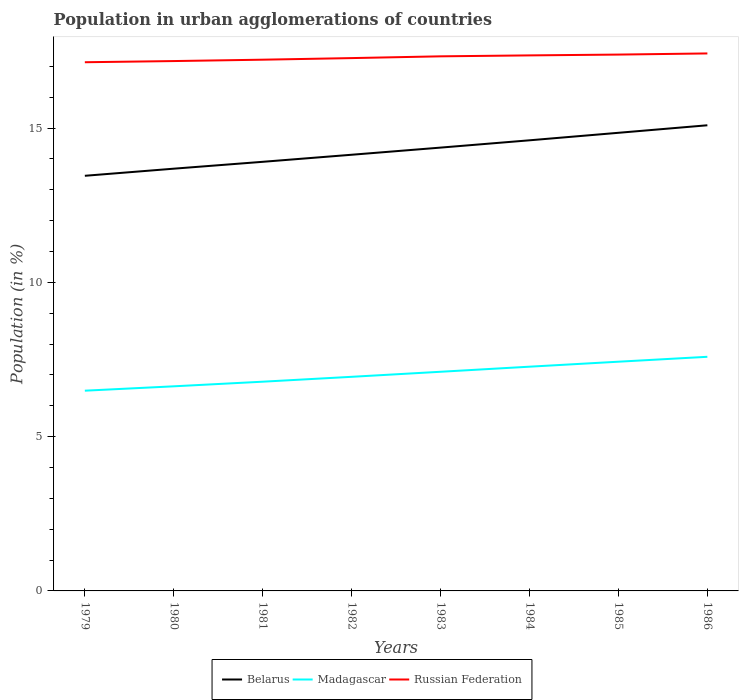Is the number of lines equal to the number of legend labels?
Keep it short and to the point. Yes. Across all years, what is the maximum percentage of population in urban agglomerations in Russian Federation?
Your response must be concise. 17.14. In which year was the percentage of population in urban agglomerations in Madagascar maximum?
Keep it short and to the point. 1979. What is the total percentage of population in urban agglomerations in Madagascar in the graph?
Offer a terse response. -0.49. What is the difference between the highest and the second highest percentage of population in urban agglomerations in Madagascar?
Ensure brevity in your answer.  1.1. Is the percentage of population in urban agglomerations in Madagascar strictly greater than the percentage of population in urban agglomerations in Belarus over the years?
Offer a terse response. Yes. Are the values on the major ticks of Y-axis written in scientific E-notation?
Ensure brevity in your answer.  No. Does the graph contain any zero values?
Your response must be concise. No. Does the graph contain grids?
Give a very brief answer. No. Where does the legend appear in the graph?
Provide a succinct answer. Bottom center. What is the title of the graph?
Your answer should be compact. Population in urban agglomerations of countries. What is the label or title of the X-axis?
Provide a succinct answer. Years. What is the Population (in %) of Belarus in 1979?
Your answer should be compact. 13.46. What is the Population (in %) of Madagascar in 1979?
Your answer should be compact. 6.49. What is the Population (in %) of Russian Federation in 1979?
Give a very brief answer. 17.14. What is the Population (in %) in Belarus in 1980?
Your response must be concise. 13.69. What is the Population (in %) of Madagascar in 1980?
Offer a very short reply. 6.63. What is the Population (in %) in Russian Federation in 1980?
Ensure brevity in your answer.  17.17. What is the Population (in %) of Belarus in 1981?
Your response must be concise. 13.91. What is the Population (in %) of Madagascar in 1981?
Give a very brief answer. 6.78. What is the Population (in %) in Russian Federation in 1981?
Your answer should be compact. 17.22. What is the Population (in %) of Belarus in 1982?
Keep it short and to the point. 14.14. What is the Population (in %) in Madagascar in 1982?
Your answer should be compact. 6.94. What is the Population (in %) of Russian Federation in 1982?
Give a very brief answer. 17.27. What is the Population (in %) of Belarus in 1983?
Offer a terse response. 14.37. What is the Population (in %) of Madagascar in 1983?
Your answer should be compact. 7.1. What is the Population (in %) of Russian Federation in 1983?
Offer a very short reply. 17.33. What is the Population (in %) in Belarus in 1984?
Your answer should be very brief. 14.61. What is the Population (in %) in Madagascar in 1984?
Your answer should be compact. 7.27. What is the Population (in %) in Russian Federation in 1984?
Your response must be concise. 17.36. What is the Population (in %) in Belarus in 1985?
Your answer should be very brief. 14.85. What is the Population (in %) in Madagascar in 1985?
Your response must be concise. 7.43. What is the Population (in %) of Russian Federation in 1985?
Keep it short and to the point. 17.38. What is the Population (in %) of Belarus in 1986?
Offer a terse response. 15.09. What is the Population (in %) in Madagascar in 1986?
Offer a very short reply. 7.59. What is the Population (in %) of Russian Federation in 1986?
Your response must be concise. 17.42. Across all years, what is the maximum Population (in %) in Belarus?
Offer a terse response. 15.09. Across all years, what is the maximum Population (in %) in Madagascar?
Make the answer very short. 7.59. Across all years, what is the maximum Population (in %) of Russian Federation?
Keep it short and to the point. 17.42. Across all years, what is the minimum Population (in %) of Belarus?
Your answer should be compact. 13.46. Across all years, what is the minimum Population (in %) of Madagascar?
Make the answer very short. 6.49. Across all years, what is the minimum Population (in %) in Russian Federation?
Offer a very short reply. 17.14. What is the total Population (in %) of Belarus in the graph?
Provide a succinct answer. 114.1. What is the total Population (in %) of Madagascar in the graph?
Make the answer very short. 56.23. What is the total Population (in %) in Russian Federation in the graph?
Your answer should be very brief. 138.29. What is the difference between the Population (in %) in Belarus in 1979 and that in 1980?
Make the answer very short. -0.23. What is the difference between the Population (in %) of Madagascar in 1979 and that in 1980?
Your answer should be very brief. -0.14. What is the difference between the Population (in %) of Russian Federation in 1979 and that in 1980?
Provide a succinct answer. -0.04. What is the difference between the Population (in %) of Belarus in 1979 and that in 1981?
Keep it short and to the point. -0.45. What is the difference between the Population (in %) of Madagascar in 1979 and that in 1981?
Provide a short and direct response. -0.29. What is the difference between the Population (in %) of Russian Federation in 1979 and that in 1981?
Make the answer very short. -0.08. What is the difference between the Population (in %) of Belarus in 1979 and that in 1982?
Offer a terse response. -0.68. What is the difference between the Population (in %) in Madagascar in 1979 and that in 1982?
Provide a short and direct response. -0.45. What is the difference between the Population (in %) of Russian Federation in 1979 and that in 1982?
Ensure brevity in your answer.  -0.13. What is the difference between the Population (in %) of Belarus in 1979 and that in 1983?
Your response must be concise. -0.91. What is the difference between the Population (in %) of Madagascar in 1979 and that in 1983?
Your answer should be very brief. -0.61. What is the difference between the Population (in %) of Russian Federation in 1979 and that in 1983?
Provide a succinct answer. -0.19. What is the difference between the Population (in %) of Belarus in 1979 and that in 1984?
Your answer should be compact. -1.15. What is the difference between the Population (in %) in Madagascar in 1979 and that in 1984?
Provide a short and direct response. -0.78. What is the difference between the Population (in %) in Russian Federation in 1979 and that in 1984?
Ensure brevity in your answer.  -0.22. What is the difference between the Population (in %) of Belarus in 1979 and that in 1985?
Offer a terse response. -1.39. What is the difference between the Population (in %) in Madagascar in 1979 and that in 1985?
Your answer should be very brief. -0.94. What is the difference between the Population (in %) in Russian Federation in 1979 and that in 1985?
Your answer should be very brief. -0.25. What is the difference between the Population (in %) of Belarus in 1979 and that in 1986?
Offer a very short reply. -1.64. What is the difference between the Population (in %) of Madagascar in 1979 and that in 1986?
Ensure brevity in your answer.  -1.1. What is the difference between the Population (in %) in Russian Federation in 1979 and that in 1986?
Make the answer very short. -0.28. What is the difference between the Population (in %) of Belarus in 1980 and that in 1981?
Your answer should be compact. -0.22. What is the difference between the Population (in %) of Madagascar in 1980 and that in 1981?
Provide a short and direct response. -0.15. What is the difference between the Population (in %) in Russian Federation in 1980 and that in 1981?
Your answer should be very brief. -0.04. What is the difference between the Population (in %) in Belarus in 1980 and that in 1982?
Provide a succinct answer. -0.45. What is the difference between the Population (in %) of Madagascar in 1980 and that in 1982?
Make the answer very short. -0.31. What is the difference between the Population (in %) of Russian Federation in 1980 and that in 1982?
Your answer should be compact. -0.1. What is the difference between the Population (in %) of Belarus in 1980 and that in 1983?
Ensure brevity in your answer.  -0.68. What is the difference between the Population (in %) of Madagascar in 1980 and that in 1983?
Your answer should be compact. -0.47. What is the difference between the Population (in %) of Russian Federation in 1980 and that in 1983?
Ensure brevity in your answer.  -0.15. What is the difference between the Population (in %) of Belarus in 1980 and that in 1984?
Offer a very short reply. -0.92. What is the difference between the Population (in %) of Madagascar in 1980 and that in 1984?
Your answer should be compact. -0.64. What is the difference between the Population (in %) in Russian Federation in 1980 and that in 1984?
Keep it short and to the point. -0.18. What is the difference between the Population (in %) in Belarus in 1980 and that in 1985?
Give a very brief answer. -1.16. What is the difference between the Population (in %) in Madagascar in 1980 and that in 1985?
Give a very brief answer. -0.8. What is the difference between the Population (in %) of Russian Federation in 1980 and that in 1985?
Your answer should be very brief. -0.21. What is the difference between the Population (in %) of Belarus in 1980 and that in 1986?
Provide a short and direct response. -1.41. What is the difference between the Population (in %) in Madagascar in 1980 and that in 1986?
Provide a short and direct response. -0.96. What is the difference between the Population (in %) of Russian Federation in 1980 and that in 1986?
Your response must be concise. -0.25. What is the difference between the Population (in %) of Belarus in 1981 and that in 1982?
Your answer should be compact. -0.23. What is the difference between the Population (in %) in Madagascar in 1981 and that in 1982?
Your response must be concise. -0.16. What is the difference between the Population (in %) in Russian Federation in 1981 and that in 1982?
Keep it short and to the point. -0.05. What is the difference between the Population (in %) in Belarus in 1981 and that in 1983?
Ensure brevity in your answer.  -0.46. What is the difference between the Population (in %) of Madagascar in 1981 and that in 1983?
Ensure brevity in your answer.  -0.32. What is the difference between the Population (in %) of Russian Federation in 1981 and that in 1983?
Your answer should be compact. -0.11. What is the difference between the Population (in %) of Belarus in 1981 and that in 1984?
Give a very brief answer. -0.7. What is the difference between the Population (in %) of Madagascar in 1981 and that in 1984?
Give a very brief answer. -0.49. What is the difference between the Population (in %) of Russian Federation in 1981 and that in 1984?
Make the answer very short. -0.14. What is the difference between the Population (in %) of Belarus in 1981 and that in 1985?
Offer a terse response. -0.94. What is the difference between the Population (in %) of Madagascar in 1981 and that in 1985?
Your response must be concise. -0.65. What is the difference between the Population (in %) of Russian Federation in 1981 and that in 1985?
Make the answer very short. -0.17. What is the difference between the Population (in %) in Belarus in 1981 and that in 1986?
Your answer should be very brief. -1.18. What is the difference between the Population (in %) of Madagascar in 1981 and that in 1986?
Your response must be concise. -0.81. What is the difference between the Population (in %) in Russian Federation in 1981 and that in 1986?
Your answer should be very brief. -0.2. What is the difference between the Population (in %) in Belarus in 1982 and that in 1983?
Provide a succinct answer. -0.23. What is the difference between the Population (in %) of Madagascar in 1982 and that in 1983?
Keep it short and to the point. -0.16. What is the difference between the Population (in %) in Russian Federation in 1982 and that in 1983?
Provide a succinct answer. -0.06. What is the difference between the Population (in %) of Belarus in 1982 and that in 1984?
Your answer should be compact. -0.47. What is the difference between the Population (in %) of Madagascar in 1982 and that in 1984?
Give a very brief answer. -0.33. What is the difference between the Population (in %) of Russian Federation in 1982 and that in 1984?
Give a very brief answer. -0.09. What is the difference between the Population (in %) of Belarus in 1982 and that in 1985?
Your response must be concise. -0.71. What is the difference between the Population (in %) in Madagascar in 1982 and that in 1985?
Keep it short and to the point. -0.49. What is the difference between the Population (in %) of Russian Federation in 1982 and that in 1985?
Your answer should be compact. -0.11. What is the difference between the Population (in %) in Belarus in 1982 and that in 1986?
Provide a short and direct response. -0.96. What is the difference between the Population (in %) of Madagascar in 1982 and that in 1986?
Provide a short and direct response. -0.65. What is the difference between the Population (in %) of Russian Federation in 1982 and that in 1986?
Your answer should be very brief. -0.15. What is the difference between the Population (in %) of Belarus in 1983 and that in 1984?
Provide a succinct answer. -0.24. What is the difference between the Population (in %) in Madagascar in 1983 and that in 1984?
Offer a terse response. -0.16. What is the difference between the Population (in %) in Russian Federation in 1983 and that in 1984?
Provide a short and direct response. -0.03. What is the difference between the Population (in %) in Belarus in 1983 and that in 1985?
Provide a succinct answer. -0.48. What is the difference between the Population (in %) in Madagascar in 1983 and that in 1985?
Your response must be concise. -0.33. What is the difference between the Population (in %) of Russian Federation in 1983 and that in 1985?
Your response must be concise. -0.06. What is the difference between the Population (in %) in Belarus in 1983 and that in 1986?
Make the answer very short. -0.72. What is the difference between the Population (in %) of Madagascar in 1983 and that in 1986?
Your response must be concise. -0.49. What is the difference between the Population (in %) in Russian Federation in 1983 and that in 1986?
Your answer should be very brief. -0.09. What is the difference between the Population (in %) of Belarus in 1984 and that in 1985?
Provide a succinct answer. -0.24. What is the difference between the Population (in %) in Madagascar in 1984 and that in 1985?
Your response must be concise. -0.16. What is the difference between the Population (in %) of Russian Federation in 1984 and that in 1985?
Offer a terse response. -0.03. What is the difference between the Population (in %) in Belarus in 1984 and that in 1986?
Offer a terse response. -0.49. What is the difference between the Population (in %) in Madagascar in 1984 and that in 1986?
Ensure brevity in your answer.  -0.32. What is the difference between the Population (in %) in Russian Federation in 1984 and that in 1986?
Keep it short and to the point. -0.06. What is the difference between the Population (in %) of Belarus in 1985 and that in 1986?
Your response must be concise. -0.24. What is the difference between the Population (in %) in Madagascar in 1985 and that in 1986?
Give a very brief answer. -0.16. What is the difference between the Population (in %) in Russian Federation in 1985 and that in 1986?
Your response must be concise. -0.04. What is the difference between the Population (in %) in Belarus in 1979 and the Population (in %) in Madagascar in 1980?
Your response must be concise. 6.82. What is the difference between the Population (in %) of Belarus in 1979 and the Population (in %) of Russian Federation in 1980?
Keep it short and to the point. -3.72. What is the difference between the Population (in %) of Madagascar in 1979 and the Population (in %) of Russian Federation in 1980?
Your response must be concise. -10.68. What is the difference between the Population (in %) of Belarus in 1979 and the Population (in %) of Madagascar in 1981?
Keep it short and to the point. 6.67. What is the difference between the Population (in %) in Belarus in 1979 and the Population (in %) in Russian Federation in 1981?
Your response must be concise. -3.76. What is the difference between the Population (in %) in Madagascar in 1979 and the Population (in %) in Russian Federation in 1981?
Offer a terse response. -10.73. What is the difference between the Population (in %) in Belarus in 1979 and the Population (in %) in Madagascar in 1982?
Make the answer very short. 6.52. What is the difference between the Population (in %) in Belarus in 1979 and the Population (in %) in Russian Federation in 1982?
Give a very brief answer. -3.81. What is the difference between the Population (in %) in Madagascar in 1979 and the Population (in %) in Russian Federation in 1982?
Provide a short and direct response. -10.78. What is the difference between the Population (in %) of Belarus in 1979 and the Population (in %) of Madagascar in 1983?
Your answer should be very brief. 6.35. What is the difference between the Population (in %) of Belarus in 1979 and the Population (in %) of Russian Federation in 1983?
Keep it short and to the point. -3.87. What is the difference between the Population (in %) of Madagascar in 1979 and the Population (in %) of Russian Federation in 1983?
Keep it short and to the point. -10.84. What is the difference between the Population (in %) in Belarus in 1979 and the Population (in %) in Madagascar in 1984?
Your answer should be compact. 6.19. What is the difference between the Population (in %) in Belarus in 1979 and the Population (in %) in Russian Federation in 1984?
Offer a terse response. -3.9. What is the difference between the Population (in %) of Madagascar in 1979 and the Population (in %) of Russian Federation in 1984?
Keep it short and to the point. -10.87. What is the difference between the Population (in %) of Belarus in 1979 and the Population (in %) of Madagascar in 1985?
Provide a succinct answer. 6.03. What is the difference between the Population (in %) of Belarus in 1979 and the Population (in %) of Russian Federation in 1985?
Keep it short and to the point. -3.93. What is the difference between the Population (in %) in Madagascar in 1979 and the Population (in %) in Russian Federation in 1985?
Keep it short and to the point. -10.89. What is the difference between the Population (in %) of Belarus in 1979 and the Population (in %) of Madagascar in 1986?
Provide a succinct answer. 5.87. What is the difference between the Population (in %) of Belarus in 1979 and the Population (in %) of Russian Federation in 1986?
Offer a terse response. -3.97. What is the difference between the Population (in %) in Madagascar in 1979 and the Population (in %) in Russian Federation in 1986?
Offer a very short reply. -10.93. What is the difference between the Population (in %) of Belarus in 1980 and the Population (in %) of Madagascar in 1981?
Offer a very short reply. 6.9. What is the difference between the Population (in %) of Belarus in 1980 and the Population (in %) of Russian Federation in 1981?
Give a very brief answer. -3.53. What is the difference between the Population (in %) in Madagascar in 1980 and the Population (in %) in Russian Federation in 1981?
Offer a very short reply. -10.59. What is the difference between the Population (in %) in Belarus in 1980 and the Population (in %) in Madagascar in 1982?
Provide a succinct answer. 6.75. What is the difference between the Population (in %) in Belarus in 1980 and the Population (in %) in Russian Federation in 1982?
Your answer should be very brief. -3.58. What is the difference between the Population (in %) in Madagascar in 1980 and the Population (in %) in Russian Federation in 1982?
Ensure brevity in your answer.  -10.64. What is the difference between the Population (in %) in Belarus in 1980 and the Population (in %) in Madagascar in 1983?
Provide a succinct answer. 6.58. What is the difference between the Population (in %) of Belarus in 1980 and the Population (in %) of Russian Federation in 1983?
Offer a very short reply. -3.64. What is the difference between the Population (in %) of Madagascar in 1980 and the Population (in %) of Russian Federation in 1983?
Provide a short and direct response. -10.7. What is the difference between the Population (in %) of Belarus in 1980 and the Population (in %) of Madagascar in 1984?
Provide a short and direct response. 6.42. What is the difference between the Population (in %) of Belarus in 1980 and the Population (in %) of Russian Federation in 1984?
Provide a short and direct response. -3.67. What is the difference between the Population (in %) in Madagascar in 1980 and the Population (in %) in Russian Federation in 1984?
Your answer should be very brief. -10.73. What is the difference between the Population (in %) in Belarus in 1980 and the Population (in %) in Madagascar in 1985?
Offer a very short reply. 6.26. What is the difference between the Population (in %) in Belarus in 1980 and the Population (in %) in Russian Federation in 1985?
Your response must be concise. -3.7. What is the difference between the Population (in %) of Madagascar in 1980 and the Population (in %) of Russian Federation in 1985?
Provide a short and direct response. -10.75. What is the difference between the Population (in %) of Belarus in 1980 and the Population (in %) of Madagascar in 1986?
Keep it short and to the point. 6.1. What is the difference between the Population (in %) of Belarus in 1980 and the Population (in %) of Russian Federation in 1986?
Provide a short and direct response. -3.74. What is the difference between the Population (in %) of Madagascar in 1980 and the Population (in %) of Russian Federation in 1986?
Your answer should be compact. -10.79. What is the difference between the Population (in %) in Belarus in 1981 and the Population (in %) in Madagascar in 1982?
Provide a succinct answer. 6.97. What is the difference between the Population (in %) of Belarus in 1981 and the Population (in %) of Russian Federation in 1982?
Provide a short and direct response. -3.36. What is the difference between the Population (in %) in Madagascar in 1981 and the Population (in %) in Russian Federation in 1982?
Offer a terse response. -10.49. What is the difference between the Population (in %) of Belarus in 1981 and the Population (in %) of Madagascar in 1983?
Make the answer very short. 6.81. What is the difference between the Population (in %) of Belarus in 1981 and the Population (in %) of Russian Federation in 1983?
Give a very brief answer. -3.42. What is the difference between the Population (in %) in Madagascar in 1981 and the Population (in %) in Russian Federation in 1983?
Ensure brevity in your answer.  -10.55. What is the difference between the Population (in %) of Belarus in 1981 and the Population (in %) of Madagascar in 1984?
Ensure brevity in your answer.  6.64. What is the difference between the Population (in %) of Belarus in 1981 and the Population (in %) of Russian Federation in 1984?
Your response must be concise. -3.45. What is the difference between the Population (in %) in Madagascar in 1981 and the Population (in %) in Russian Federation in 1984?
Your answer should be compact. -10.58. What is the difference between the Population (in %) of Belarus in 1981 and the Population (in %) of Madagascar in 1985?
Your answer should be compact. 6.48. What is the difference between the Population (in %) in Belarus in 1981 and the Population (in %) in Russian Federation in 1985?
Keep it short and to the point. -3.48. What is the difference between the Population (in %) in Madagascar in 1981 and the Population (in %) in Russian Federation in 1985?
Your response must be concise. -10.6. What is the difference between the Population (in %) of Belarus in 1981 and the Population (in %) of Madagascar in 1986?
Ensure brevity in your answer.  6.32. What is the difference between the Population (in %) of Belarus in 1981 and the Population (in %) of Russian Federation in 1986?
Your answer should be compact. -3.51. What is the difference between the Population (in %) of Madagascar in 1981 and the Population (in %) of Russian Federation in 1986?
Your answer should be compact. -10.64. What is the difference between the Population (in %) in Belarus in 1982 and the Population (in %) in Madagascar in 1983?
Provide a succinct answer. 7.03. What is the difference between the Population (in %) in Belarus in 1982 and the Population (in %) in Russian Federation in 1983?
Your response must be concise. -3.19. What is the difference between the Population (in %) in Madagascar in 1982 and the Population (in %) in Russian Federation in 1983?
Make the answer very short. -10.39. What is the difference between the Population (in %) of Belarus in 1982 and the Population (in %) of Madagascar in 1984?
Offer a very short reply. 6.87. What is the difference between the Population (in %) of Belarus in 1982 and the Population (in %) of Russian Federation in 1984?
Provide a short and direct response. -3.22. What is the difference between the Population (in %) in Madagascar in 1982 and the Population (in %) in Russian Federation in 1984?
Ensure brevity in your answer.  -10.42. What is the difference between the Population (in %) of Belarus in 1982 and the Population (in %) of Madagascar in 1985?
Give a very brief answer. 6.71. What is the difference between the Population (in %) in Belarus in 1982 and the Population (in %) in Russian Federation in 1985?
Make the answer very short. -3.25. What is the difference between the Population (in %) in Madagascar in 1982 and the Population (in %) in Russian Federation in 1985?
Your answer should be compact. -10.44. What is the difference between the Population (in %) in Belarus in 1982 and the Population (in %) in Madagascar in 1986?
Ensure brevity in your answer.  6.55. What is the difference between the Population (in %) of Belarus in 1982 and the Population (in %) of Russian Federation in 1986?
Your answer should be very brief. -3.28. What is the difference between the Population (in %) of Madagascar in 1982 and the Population (in %) of Russian Federation in 1986?
Give a very brief answer. -10.48. What is the difference between the Population (in %) in Belarus in 1983 and the Population (in %) in Madagascar in 1984?
Provide a succinct answer. 7.1. What is the difference between the Population (in %) in Belarus in 1983 and the Population (in %) in Russian Federation in 1984?
Keep it short and to the point. -2.99. What is the difference between the Population (in %) in Madagascar in 1983 and the Population (in %) in Russian Federation in 1984?
Keep it short and to the point. -10.25. What is the difference between the Population (in %) in Belarus in 1983 and the Population (in %) in Madagascar in 1985?
Ensure brevity in your answer.  6.94. What is the difference between the Population (in %) in Belarus in 1983 and the Population (in %) in Russian Federation in 1985?
Make the answer very short. -3.02. What is the difference between the Population (in %) in Madagascar in 1983 and the Population (in %) in Russian Federation in 1985?
Provide a succinct answer. -10.28. What is the difference between the Population (in %) in Belarus in 1983 and the Population (in %) in Madagascar in 1986?
Provide a short and direct response. 6.78. What is the difference between the Population (in %) of Belarus in 1983 and the Population (in %) of Russian Federation in 1986?
Make the answer very short. -3.05. What is the difference between the Population (in %) in Madagascar in 1983 and the Population (in %) in Russian Federation in 1986?
Your response must be concise. -10.32. What is the difference between the Population (in %) of Belarus in 1984 and the Population (in %) of Madagascar in 1985?
Provide a short and direct response. 7.18. What is the difference between the Population (in %) of Belarus in 1984 and the Population (in %) of Russian Federation in 1985?
Your response must be concise. -2.78. What is the difference between the Population (in %) of Madagascar in 1984 and the Population (in %) of Russian Federation in 1985?
Your answer should be very brief. -10.12. What is the difference between the Population (in %) in Belarus in 1984 and the Population (in %) in Madagascar in 1986?
Make the answer very short. 7.02. What is the difference between the Population (in %) of Belarus in 1984 and the Population (in %) of Russian Federation in 1986?
Give a very brief answer. -2.82. What is the difference between the Population (in %) of Madagascar in 1984 and the Population (in %) of Russian Federation in 1986?
Make the answer very short. -10.15. What is the difference between the Population (in %) of Belarus in 1985 and the Population (in %) of Madagascar in 1986?
Your answer should be compact. 7.26. What is the difference between the Population (in %) in Belarus in 1985 and the Population (in %) in Russian Federation in 1986?
Offer a very short reply. -2.57. What is the difference between the Population (in %) of Madagascar in 1985 and the Population (in %) of Russian Federation in 1986?
Keep it short and to the point. -9.99. What is the average Population (in %) in Belarus per year?
Make the answer very short. 14.26. What is the average Population (in %) of Madagascar per year?
Keep it short and to the point. 7.03. What is the average Population (in %) in Russian Federation per year?
Keep it short and to the point. 17.29. In the year 1979, what is the difference between the Population (in %) in Belarus and Population (in %) in Madagascar?
Keep it short and to the point. 6.97. In the year 1979, what is the difference between the Population (in %) in Belarus and Population (in %) in Russian Federation?
Offer a terse response. -3.68. In the year 1979, what is the difference between the Population (in %) of Madagascar and Population (in %) of Russian Federation?
Make the answer very short. -10.65. In the year 1980, what is the difference between the Population (in %) of Belarus and Population (in %) of Madagascar?
Make the answer very short. 7.05. In the year 1980, what is the difference between the Population (in %) of Belarus and Population (in %) of Russian Federation?
Give a very brief answer. -3.49. In the year 1980, what is the difference between the Population (in %) of Madagascar and Population (in %) of Russian Federation?
Offer a very short reply. -10.54. In the year 1981, what is the difference between the Population (in %) of Belarus and Population (in %) of Madagascar?
Offer a terse response. 7.13. In the year 1981, what is the difference between the Population (in %) of Belarus and Population (in %) of Russian Federation?
Your answer should be compact. -3.31. In the year 1981, what is the difference between the Population (in %) in Madagascar and Population (in %) in Russian Federation?
Give a very brief answer. -10.44. In the year 1982, what is the difference between the Population (in %) of Belarus and Population (in %) of Madagascar?
Make the answer very short. 7.2. In the year 1982, what is the difference between the Population (in %) of Belarus and Population (in %) of Russian Federation?
Provide a short and direct response. -3.13. In the year 1982, what is the difference between the Population (in %) in Madagascar and Population (in %) in Russian Federation?
Your response must be concise. -10.33. In the year 1983, what is the difference between the Population (in %) in Belarus and Population (in %) in Madagascar?
Offer a very short reply. 7.27. In the year 1983, what is the difference between the Population (in %) of Belarus and Population (in %) of Russian Federation?
Keep it short and to the point. -2.96. In the year 1983, what is the difference between the Population (in %) in Madagascar and Population (in %) in Russian Federation?
Your answer should be compact. -10.22. In the year 1984, what is the difference between the Population (in %) of Belarus and Population (in %) of Madagascar?
Your answer should be very brief. 7.34. In the year 1984, what is the difference between the Population (in %) of Belarus and Population (in %) of Russian Federation?
Your answer should be very brief. -2.75. In the year 1984, what is the difference between the Population (in %) in Madagascar and Population (in %) in Russian Federation?
Provide a short and direct response. -10.09. In the year 1985, what is the difference between the Population (in %) of Belarus and Population (in %) of Madagascar?
Keep it short and to the point. 7.42. In the year 1985, what is the difference between the Population (in %) of Belarus and Population (in %) of Russian Federation?
Ensure brevity in your answer.  -2.54. In the year 1985, what is the difference between the Population (in %) in Madagascar and Population (in %) in Russian Federation?
Provide a succinct answer. -9.95. In the year 1986, what is the difference between the Population (in %) in Belarus and Population (in %) in Madagascar?
Provide a short and direct response. 7.5. In the year 1986, what is the difference between the Population (in %) in Belarus and Population (in %) in Russian Federation?
Offer a very short reply. -2.33. In the year 1986, what is the difference between the Population (in %) of Madagascar and Population (in %) of Russian Federation?
Offer a terse response. -9.83. What is the ratio of the Population (in %) of Belarus in 1979 to that in 1980?
Ensure brevity in your answer.  0.98. What is the ratio of the Population (in %) in Madagascar in 1979 to that in 1980?
Provide a short and direct response. 0.98. What is the ratio of the Population (in %) of Russian Federation in 1979 to that in 1980?
Give a very brief answer. 1. What is the ratio of the Population (in %) in Belarus in 1979 to that in 1981?
Your answer should be compact. 0.97. What is the ratio of the Population (in %) in Russian Federation in 1979 to that in 1981?
Your response must be concise. 1. What is the ratio of the Population (in %) in Belarus in 1979 to that in 1982?
Offer a very short reply. 0.95. What is the ratio of the Population (in %) in Madagascar in 1979 to that in 1982?
Provide a succinct answer. 0.94. What is the ratio of the Population (in %) of Russian Federation in 1979 to that in 1982?
Your answer should be very brief. 0.99. What is the ratio of the Population (in %) in Belarus in 1979 to that in 1983?
Your response must be concise. 0.94. What is the ratio of the Population (in %) in Madagascar in 1979 to that in 1983?
Offer a very short reply. 0.91. What is the ratio of the Population (in %) of Belarus in 1979 to that in 1984?
Offer a very short reply. 0.92. What is the ratio of the Population (in %) of Madagascar in 1979 to that in 1984?
Your answer should be very brief. 0.89. What is the ratio of the Population (in %) in Russian Federation in 1979 to that in 1984?
Your answer should be very brief. 0.99. What is the ratio of the Population (in %) in Belarus in 1979 to that in 1985?
Your answer should be very brief. 0.91. What is the ratio of the Population (in %) in Madagascar in 1979 to that in 1985?
Your answer should be very brief. 0.87. What is the ratio of the Population (in %) of Russian Federation in 1979 to that in 1985?
Offer a terse response. 0.99. What is the ratio of the Population (in %) in Belarus in 1979 to that in 1986?
Give a very brief answer. 0.89. What is the ratio of the Population (in %) in Madagascar in 1979 to that in 1986?
Provide a short and direct response. 0.86. What is the ratio of the Population (in %) in Russian Federation in 1979 to that in 1986?
Your response must be concise. 0.98. What is the ratio of the Population (in %) of Belarus in 1980 to that in 1981?
Offer a terse response. 0.98. What is the ratio of the Population (in %) of Madagascar in 1980 to that in 1981?
Offer a very short reply. 0.98. What is the ratio of the Population (in %) in Belarus in 1980 to that in 1982?
Provide a succinct answer. 0.97. What is the ratio of the Population (in %) in Madagascar in 1980 to that in 1982?
Make the answer very short. 0.96. What is the ratio of the Population (in %) of Russian Federation in 1980 to that in 1982?
Offer a very short reply. 0.99. What is the ratio of the Population (in %) of Belarus in 1980 to that in 1983?
Your answer should be very brief. 0.95. What is the ratio of the Population (in %) in Madagascar in 1980 to that in 1983?
Give a very brief answer. 0.93. What is the ratio of the Population (in %) of Belarus in 1980 to that in 1984?
Provide a short and direct response. 0.94. What is the ratio of the Population (in %) of Madagascar in 1980 to that in 1984?
Ensure brevity in your answer.  0.91. What is the ratio of the Population (in %) of Belarus in 1980 to that in 1985?
Provide a short and direct response. 0.92. What is the ratio of the Population (in %) in Madagascar in 1980 to that in 1985?
Provide a succinct answer. 0.89. What is the ratio of the Population (in %) of Russian Federation in 1980 to that in 1985?
Your answer should be very brief. 0.99. What is the ratio of the Population (in %) of Belarus in 1980 to that in 1986?
Make the answer very short. 0.91. What is the ratio of the Population (in %) of Madagascar in 1980 to that in 1986?
Make the answer very short. 0.87. What is the ratio of the Population (in %) of Russian Federation in 1980 to that in 1986?
Provide a succinct answer. 0.99. What is the ratio of the Population (in %) in Belarus in 1981 to that in 1982?
Provide a short and direct response. 0.98. What is the ratio of the Population (in %) of Madagascar in 1981 to that in 1982?
Offer a terse response. 0.98. What is the ratio of the Population (in %) in Russian Federation in 1981 to that in 1982?
Your response must be concise. 1. What is the ratio of the Population (in %) in Madagascar in 1981 to that in 1983?
Make the answer very short. 0.95. What is the ratio of the Population (in %) in Belarus in 1981 to that in 1984?
Provide a succinct answer. 0.95. What is the ratio of the Population (in %) of Madagascar in 1981 to that in 1984?
Your response must be concise. 0.93. What is the ratio of the Population (in %) of Russian Federation in 1981 to that in 1984?
Provide a succinct answer. 0.99. What is the ratio of the Population (in %) of Belarus in 1981 to that in 1985?
Provide a succinct answer. 0.94. What is the ratio of the Population (in %) in Madagascar in 1981 to that in 1985?
Offer a terse response. 0.91. What is the ratio of the Population (in %) in Russian Federation in 1981 to that in 1985?
Provide a short and direct response. 0.99. What is the ratio of the Population (in %) in Belarus in 1981 to that in 1986?
Give a very brief answer. 0.92. What is the ratio of the Population (in %) of Madagascar in 1981 to that in 1986?
Offer a terse response. 0.89. What is the ratio of the Population (in %) in Russian Federation in 1981 to that in 1986?
Your answer should be very brief. 0.99. What is the ratio of the Population (in %) in Belarus in 1982 to that in 1983?
Offer a very short reply. 0.98. What is the ratio of the Population (in %) in Russian Federation in 1982 to that in 1983?
Provide a succinct answer. 1. What is the ratio of the Population (in %) of Belarus in 1982 to that in 1984?
Your answer should be compact. 0.97. What is the ratio of the Population (in %) of Madagascar in 1982 to that in 1984?
Your response must be concise. 0.95. What is the ratio of the Population (in %) in Belarus in 1982 to that in 1985?
Provide a short and direct response. 0.95. What is the ratio of the Population (in %) of Madagascar in 1982 to that in 1985?
Make the answer very short. 0.93. What is the ratio of the Population (in %) of Russian Federation in 1982 to that in 1985?
Offer a terse response. 0.99. What is the ratio of the Population (in %) of Belarus in 1982 to that in 1986?
Keep it short and to the point. 0.94. What is the ratio of the Population (in %) in Madagascar in 1982 to that in 1986?
Your response must be concise. 0.91. What is the ratio of the Population (in %) of Russian Federation in 1982 to that in 1986?
Your answer should be compact. 0.99. What is the ratio of the Population (in %) in Belarus in 1983 to that in 1984?
Offer a terse response. 0.98. What is the ratio of the Population (in %) in Madagascar in 1983 to that in 1984?
Offer a terse response. 0.98. What is the ratio of the Population (in %) of Russian Federation in 1983 to that in 1984?
Make the answer very short. 1. What is the ratio of the Population (in %) of Belarus in 1983 to that in 1985?
Offer a terse response. 0.97. What is the ratio of the Population (in %) in Madagascar in 1983 to that in 1985?
Provide a succinct answer. 0.96. What is the ratio of the Population (in %) of Russian Federation in 1983 to that in 1985?
Offer a terse response. 1. What is the ratio of the Population (in %) in Madagascar in 1983 to that in 1986?
Ensure brevity in your answer.  0.94. What is the ratio of the Population (in %) in Russian Federation in 1983 to that in 1986?
Offer a terse response. 0.99. What is the ratio of the Population (in %) in Belarus in 1984 to that in 1985?
Your answer should be compact. 0.98. What is the ratio of the Population (in %) in Madagascar in 1984 to that in 1985?
Keep it short and to the point. 0.98. What is the ratio of the Population (in %) in Russian Federation in 1984 to that in 1985?
Give a very brief answer. 1. What is the ratio of the Population (in %) in Madagascar in 1984 to that in 1986?
Offer a very short reply. 0.96. What is the ratio of the Population (in %) in Belarus in 1985 to that in 1986?
Offer a terse response. 0.98. What is the ratio of the Population (in %) in Madagascar in 1985 to that in 1986?
Keep it short and to the point. 0.98. What is the difference between the highest and the second highest Population (in %) of Belarus?
Provide a succinct answer. 0.24. What is the difference between the highest and the second highest Population (in %) of Madagascar?
Offer a very short reply. 0.16. What is the difference between the highest and the second highest Population (in %) of Russian Federation?
Your answer should be compact. 0.04. What is the difference between the highest and the lowest Population (in %) of Belarus?
Provide a short and direct response. 1.64. What is the difference between the highest and the lowest Population (in %) of Madagascar?
Keep it short and to the point. 1.1. What is the difference between the highest and the lowest Population (in %) of Russian Federation?
Ensure brevity in your answer.  0.28. 